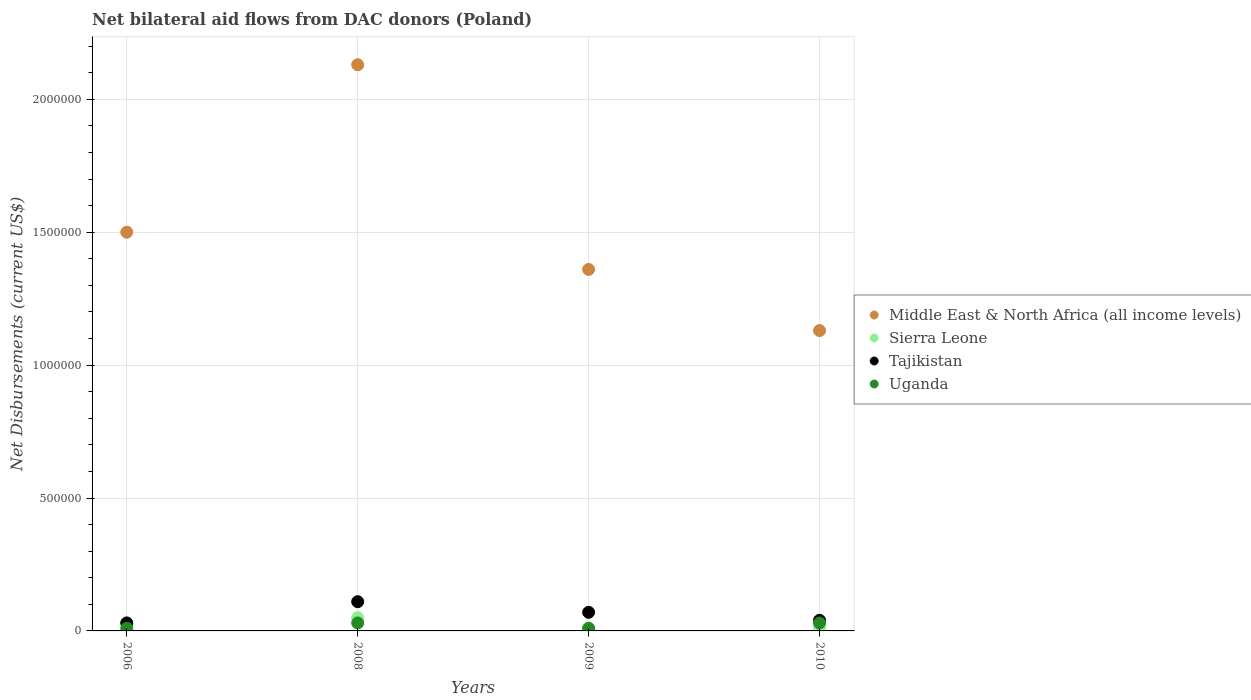Is the number of dotlines equal to the number of legend labels?
Provide a succinct answer. Yes. What is the net bilateral aid flows in Uganda in 2008?
Offer a terse response. 3.00e+04. Across all years, what is the maximum net bilateral aid flows in Middle East & North Africa (all income levels)?
Give a very brief answer. 2.13e+06. Across all years, what is the minimum net bilateral aid flows in Middle East & North Africa (all income levels)?
Make the answer very short. 1.13e+06. What is the total net bilateral aid flows in Tajikistan in the graph?
Provide a short and direct response. 2.50e+05. What is the difference between the net bilateral aid flows in Middle East & North Africa (all income levels) in 2009 and that in 2010?
Provide a short and direct response. 2.30e+05. What is the difference between the net bilateral aid flows in Middle East & North Africa (all income levels) in 2010 and the net bilateral aid flows in Uganda in 2009?
Your response must be concise. 1.12e+06. What is the average net bilateral aid flows in Tajikistan per year?
Offer a terse response. 6.25e+04. In the year 2009, what is the difference between the net bilateral aid flows in Tajikistan and net bilateral aid flows in Uganda?
Make the answer very short. 6.00e+04. In how many years, is the net bilateral aid flows in Uganda greater than 1000000 US$?
Keep it short and to the point. 0. What is the ratio of the net bilateral aid flows in Middle East & North Africa (all income levels) in 2006 to that in 2010?
Offer a terse response. 1.33. In how many years, is the net bilateral aid flows in Tajikistan greater than the average net bilateral aid flows in Tajikistan taken over all years?
Your answer should be compact. 2. Is the sum of the net bilateral aid flows in Tajikistan in 2006 and 2008 greater than the maximum net bilateral aid flows in Uganda across all years?
Keep it short and to the point. Yes. How many years are there in the graph?
Give a very brief answer. 4. How are the legend labels stacked?
Your answer should be compact. Vertical. What is the title of the graph?
Make the answer very short. Net bilateral aid flows from DAC donors (Poland). Does "Central African Republic" appear as one of the legend labels in the graph?
Provide a succinct answer. No. What is the label or title of the X-axis?
Provide a short and direct response. Years. What is the label or title of the Y-axis?
Offer a terse response. Net Disbursements (current US$). What is the Net Disbursements (current US$) of Middle East & North Africa (all income levels) in 2006?
Offer a terse response. 1.50e+06. What is the Net Disbursements (current US$) of Sierra Leone in 2006?
Offer a very short reply. 3.00e+04. What is the Net Disbursements (current US$) of Uganda in 2006?
Keep it short and to the point. 10000. What is the Net Disbursements (current US$) in Middle East & North Africa (all income levels) in 2008?
Make the answer very short. 2.13e+06. What is the Net Disbursements (current US$) in Tajikistan in 2008?
Give a very brief answer. 1.10e+05. What is the Net Disbursements (current US$) of Uganda in 2008?
Your answer should be compact. 3.00e+04. What is the Net Disbursements (current US$) of Middle East & North Africa (all income levels) in 2009?
Offer a terse response. 1.36e+06. What is the Net Disbursements (current US$) in Sierra Leone in 2009?
Offer a terse response. 10000. What is the Net Disbursements (current US$) of Tajikistan in 2009?
Your answer should be very brief. 7.00e+04. What is the Net Disbursements (current US$) of Middle East & North Africa (all income levels) in 2010?
Your answer should be very brief. 1.13e+06. Across all years, what is the maximum Net Disbursements (current US$) of Middle East & North Africa (all income levels)?
Your answer should be very brief. 2.13e+06. Across all years, what is the maximum Net Disbursements (current US$) in Sierra Leone?
Offer a terse response. 5.00e+04. Across all years, what is the maximum Net Disbursements (current US$) of Uganda?
Keep it short and to the point. 3.00e+04. Across all years, what is the minimum Net Disbursements (current US$) in Middle East & North Africa (all income levels)?
Your response must be concise. 1.13e+06. What is the total Net Disbursements (current US$) in Middle East & North Africa (all income levels) in the graph?
Give a very brief answer. 6.12e+06. What is the total Net Disbursements (current US$) of Sierra Leone in the graph?
Provide a succinct answer. 1.00e+05. What is the difference between the Net Disbursements (current US$) in Middle East & North Africa (all income levels) in 2006 and that in 2008?
Provide a succinct answer. -6.30e+05. What is the difference between the Net Disbursements (current US$) in Sierra Leone in 2006 and that in 2008?
Ensure brevity in your answer.  -2.00e+04. What is the difference between the Net Disbursements (current US$) in Tajikistan in 2006 and that in 2008?
Ensure brevity in your answer.  -8.00e+04. What is the difference between the Net Disbursements (current US$) of Tajikistan in 2006 and that in 2009?
Keep it short and to the point. -4.00e+04. What is the difference between the Net Disbursements (current US$) of Uganda in 2006 and that in 2009?
Offer a very short reply. 0. What is the difference between the Net Disbursements (current US$) of Middle East & North Africa (all income levels) in 2006 and that in 2010?
Your answer should be very brief. 3.70e+05. What is the difference between the Net Disbursements (current US$) of Tajikistan in 2006 and that in 2010?
Give a very brief answer. -10000. What is the difference between the Net Disbursements (current US$) in Uganda in 2006 and that in 2010?
Provide a succinct answer. -2.00e+04. What is the difference between the Net Disbursements (current US$) in Middle East & North Africa (all income levels) in 2008 and that in 2009?
Your answer should be compact. 7.70e+05. What is the difference between the Net Disbursements (current US$) of Sierra Leone in 2008 and that in 2009?
Keep it short and to the point. 4.00e+04. What is the difference between the Net Disbursements (current US$) in Tajikistan in 2008 and that in 2009?
Make the answer very short. 4.00e+04. What is the difference between the Net Disbursements (current US$) in Uganda in 2008 and that in 2009?
Offer a terse response. 2.00e+04. What is the difference between the Net Disbursements (current US$) of Middle East & North Africa (all income levels) in 2008 and that in 2010?
Your answer should be very brief. 1.00e+06. What is the difference between the Net Disbursements (current US$) in Tajikistan in 2009 and that in 2010?
Offer a very short reply. 3.00e+04. What is the difference between the Net Disbursements (current US$) in Middle East & North Africa (all income levels) in 2006 and the Net Disbursements (current US$) in Sierra Leone in 2008?
Give a very brief answer. 1.45e+06. What is the difference between the Net Disbursements (current US$) in Middle East & North Africa (all income levels) in 2006 and the Net Disbursements (current US$) in Tajikistan in 2008?
Ensure brevity in your answer.  1.39e+06. What is the difference between the Net Disbursements (current US$) of Middle East & North Africa (all income levels) in 2006 and the Net Disbursements (current US$) of Uganda in 2008?
Your answer should be very brief. 1.47e+06. What is the difference between the Net Disbursements (current US$) of Sierra Leone in 2006 and the Net Disbursements (current US$) of Tajikistan in 2008?
Your answer should be compact. -8.00e+04. What is the difference between the Net Disbursements (current US$) in Sierra Leone in 2006 and the Net Disbursements (current US$) in Uganda in 2008?
Offer a very short reply. 0. What is the difference between the Net Disbursements (current US$) in Tajikistan in 2006 and the Net Disbursements (current US$) in Uganda in 2008?
Make the answer very short. 0. What is the difference between the Net Disbursements (current US$) in Middle East & North Africa (all income levels) in 2006 and the Net Disbursements (current US$) in Sierra Leone in 2009?
Give a very brief answer. 1.49e+06. What is the difference between the Net Disbursements (current US$) of Middle East & North Africa (all income levels) in 2006 and the Net Disbursements (current US$) of Tajikistan in 2009?
Give a very brief answer. 1.43e+06. What is the difference between the Net Disbursements (current US$) of Middle East & North Africa (all income levels) in 2006 and the Net Disbursements (current US$) of Uganda in 2009?
Keep it short and to the point. 1.49e+06. What is the difference between the Net Disbursements (current US$) in Tajikistan in 2006 and the Net Disbursements (current US$) in Uganda in 2009?
Ensure brevity in your answer.  2.00e+04. What is the difference between the Net Disbursements (current US$) of Middle East & North Africa (all income levels) in 2006 and the Net Disbursements (current US$) of Sierra Leone in 2010?
Your response must be concise. 1.49e+06. What is the difference between the Net Disbursements (current US$) of Middle East & North Africa (all income levels) in 2006 and the Net Disbursements (current US$) of Tajikistan in 2010?
Your answer should be compact. 1.46e+06. What is the difference between the Net Disbursements (current US$) of Middle East & North Africa (all income levels) in 2006 and the Net Disbursements (current US$) of Uganda in 2010?
Your answer should be very brief. 1.47e+06. What is the difference between the Net Disbursements (current US$) of Sierra Leone in 2006 and the Net Disbursements (current US$) of Tajikistan in 2010?
Keep it short and to the point. -10000. What is the difference between the Net Disbursements (current US$) in Sierra Leone in 2006 and the Net Disbursements (current US$) in Uganda in 2010?
Offer a terse response. 0. What is the difference between the Net Disbursements (current US$) of Middle East & North Africa (all income levels) in 2008 and the Net Disbursements (current US$) of Sierra Leone in 2009?
Your answer should be compact. 2.12e+06. What is the difference between the Net Disbursements (current US$) of Middle East & North Africa (all income levels) in 2008 and the Net Disbursements (current US$) of Tajikistan in 2009?
Offer a very short reply. 2.06e+06. What is the difference between the Net Disbursements (current US$) of Middle East & North Africa (all income levels) in 2008 and the Net Disbursements (current US$) of Uganda in 2009?
Ensure brevity in your answer.  2.12e+06. What is the difference between the Net Disbursements (current US$) of Sierra Leone in 2008 and the Net Disbursements (current US$) of Tajikistan in 2009?
Keep it short and to the point. -2.00e+04. What is the difference between the Net Disbursements (current US$) in Sierra Leone in 2008 and the Net Disbursements (current US$) in Uganda in 2009?
Provide a succinct answer. 4.00e+04. What is the difference between the Net Disbursements (current US$) in Middle East & North Africa (all income levels) in 2008 and the Net Disbursements (current US$) in Sierra Leone in 2010?
Offer a very short reply. 2.12e+06. What is the difference between the Net Disbursements (current US$) of Middle East & North Africa (all income levels) in 2008 and the Net Disbursements (current US$) of Tajikistan in 2010?
Give a very brief answer. 2.09e+06. What is the difference between the Net Disbursements (current US$) of Middle East & North Africa (all income levels) in 2008 and the Net Disbursements (current US$) of Uganda in 2010?
Give a very brief answer. 2.10e+06. What is the difference between the Net Disbursements (current US$) of Tajikistan in 2008 and the Net Disbursements (current US$) of Uganda in 2010?
Provide a succinct answer. 8.00e+04. What is the difference between the Net Disbursements (current US$) of Middle East & North Africa (all income levels) in 2009 and the Net Disbursements (current US$) of Sierra Leone in 2010?
Ensure brevity in your answer.  1.35e+06. What is the difference between the Net Disbursements (current US$) of Middle East & North Africa (all income levels) in 2009 and the Net Disbursements (current US$) of Tajikistan in 2010?
Provide a short and direct response. 1.32e+06. What is the difference between the Net Disbursements (current US$) in Middle East & North Africa (all income levels) in 2009 and the Net Disbursements (current US$) in Uganda in 2010?
Offer a very short reply. 1.33e+06. What is the difference between the Net Disbursements (current US$) in Sierra Leone in 2009 and the Net Disbursements (current US$) in Tajikistan in 2010?
Make the answer very short. -3.00e+04. What is the difference between the Net Disbursements (current US$) of Tajikistan in 2009 and the Net Disbursements (current US$) of Uganda in 2010?
Ensure brevity in your answer.  4.00e+04. What is the average Net Disbursements (current US$) of Middle East & North Africa (all income levels) per year?
Ensure brevity in your answer.  1.53e+06. What is the average Net Disbursements (current US$) in Sierra Leone per year?
Your response must be concise. 2.50e+04. What is the average Net Disbursements (current US$) in Tajikistan per year?
Give a very brief answer. 6.25e+04. What is the average Net Disbursements (current US$) of Uganda per year?
Provide a short and direct response. 2.00e+04. In the year 2006, what is the difference between the Net Disbursements (current US$) in Middle East & North Africa (all income levels) and Net Disbursements (current US$) in Sierra Leone?
Provide a succinct answer. 1.47e+06. In the year 2006, what is the difference between the Net Disbursements (current US$) in Middle East & North Africa (all income levels) and Net Disbursements (current US$) in Tajikistan?
Offer a terse response. 1.47e+06. In the year 2006, what is the difference between the Net Disbursements (current US$) of Middle East & North Africa (all income levels) and Net Disbursements (current US$) of Uganda?
Provide a short and direct response. 1.49e+06. In the year 2006, what is the difference between the Net Disbursements (current US$) of Sierra Leone and Net Disbursements (current US$) of Tajikistan?
Ensure brevity in your answer.  0. In the year 2006, what is the difference between the Net Disbursements (current US$) in Sierra Leone and Net Disbursements (current US$) in Uganda?
Offer a very short reply. 2.00e+04. In the year 2006, what is the difference between the Net Disbursements (current US$) in Tajikistan and Net Disbursements (current US$) in Uganda?
Your response must be concise. 2.00e+04. In the year 2008, what is the difference between the Net Disbursements (current US$) of Middle East & North Africa (all income levels) and Net Disbursements (current US$) of Sierra Leone?
Provide a succinct answer. 2.08e+06. In the year 2008, what is the difference between the Net Disbursements (current US$) in Middle East & North Africa (all income levels) and Net Disbursements (current US$) in Tajikistan?
Give a very brief answer. 2.02e+06. In the year 2008, what is the difference between the Net Disbursements (current US$) of Middle East & North Africa (all income levels) and Net Disbursements (current US$) of Uganda?
Make the answer very short. 2.10e+06. In the year 2008, what is the difference between the Net Disbursements (current US$) in Sierra Leone and Net Disbursements (current US$) in Tajikistan?
Ensure brevity in your answer.  -6.00e+04. In the year 2008, what is the difference between the Net Disbursements (current US$) in Sierra Leone and Net Disbursements (current US$) in Uganda?
Give a very brief answer. 2.00e+04. In the year 2008, what is the difference between the Net Disbursements (current US$) in Tajikistan and Net Disbursements (current US$) in Uganda?
Provide a succinct answer. 8.00e+04. In the year 2009, what is the difference between the Net Disbursements (current US$) of Middle East & North Africa (all income levels) and Net Disbursements (current US$) of Sierra Leone?
Keep it short and to the point. 1.35e+06. In the year 2009, what is the difference between the Net Disbursements (current US$) in Middle East & North Africa (all income levels) and Net Disbursements (current US$) in Tajikistan?
Offer a terse response. 1.29e+06. In the year 2009, what is the difference between the Net Disbursements (current US$) in Middle East & North Africa (all income levels) and Net Disbursements (current US$) in Uganda?
Offer a terse response. 1.35e+06. In the year 2009, what is the difference between the Net Disbursements (current US$) of Sierra Leone and Net Disbursements (current US$) of Tajikistan?
Give a very brief answer. -6.00e+04. In the year 2009, what is the difference between the Net Disbursements (current US$) of Sierra Leone and Net Disbursements (current US$) of Uganda?
Your response must be concise. 0. In the year 2009, what is the difference between the Net Disbursements (current US$) in Tajikistan and Net Disbursements (current US$) in Uganda?
Your response must be concise. 6.00e+04. In the year 2010, what is the difference between the Net Disbursements (current US$) in Middle East & North Africa (all income levels) and Net Disbursements (current US$) in Sierra Leone?
Ensure brevity in your answer.  1.12e+06. In the year 2010, what is the difference between the Net Disbursements (current US$) of Middle East & North Africa (all income levels) and Net Disbursements (current US$) of Tajikistan?
Your response must be concise. 1.09e+06. In the year 2010, what is the difference between the Net Disbursements (current US$) of Middle East & North Africa (all income levels) and Net Disbursements (current US$) of Uganda?
Give a very brief answer. 1.10e+06. In the year 2010, what is the difference between the Net Disbursements (current US$) in Sierra Leone and Net Disbursements (current US$) in Uganda?
Ensure brevity in your answer.  -2.00e+04. What is the ratio of the Net Disbursements (current US$) in Middle East & North Africa (all income levels) in 2006 to that in 2008?
Provide a short and direct response. 0.7. What is the ratio of the Net Disbursements (current US$) of Sierra Leone in 2006 to that in 2008?
Keep it short and to the point. 0.6. What is the ratio of the Net Disbursements (current US$) in Tajikistan in 2006 to that in 2008?
Make the answer very short. 0.27. What is the ratio of the Net Disbursements (current US$) in Uganda in 2006 to that in 2008?
Offer a terse response. 0.33. What is the ratio of the Net Disbursements (current US$) in Middle East & North Africa (all income levels) in 2006 to that in 2009?
Offer a terse response. 1.1. What is the ratio of the Net Disbursements (current US$) in Sierra Leone in 2006 to that in 2009?
Provide a succinct answer. 3. What is the ratio of the Net Disbursements (current US$) in Tajikistan in 2006 to that in 2009?
Offer a very short reply. 0.43. What is the ratio of the Net Disbursements (current US$) in Middle East & North Africa (all income levels) in 2006 to that in 2010?
Make the answer very short. 1.33. What is the ratio of the Net Disbursements (current US$) of Sierra Leone in 2006 to that in 2010?
Your response must be concise. 3. What is the ratio of the Net Disbursements (current US$) in Uganda in 2006 to that in 2010?
Offer a terse response. 0.33. What is the ratio of the Net Disbursements (current US$) of Middle East & North Africa (all income levels) in 2008 to that in 2009?
Your response must be concise. 1.57. What is the ratio of the Net Disbursements (current US$) in Sierra Leone in 2008 to that in 2009?
Ensure brevity in your answer.  5. What is the ratio of the Net Disbursements (current US$) of Tajikistan in 2008 to that in 2009?
Keep it short and to the point. 1.57. What is the ratio of the Net Disbursements (current US$) in Middle East & North Africa (all income levels) in 2008 to that in 2010?
Your response must be concise. 1.89. What is the ratio of the Net Disbursements (current US$) of Sierra Leone in 2008 to that in 2010?
Offer a terse response. 5. What is the ratio of the Net Disbursements (current US$) of Tajikistan in 2008 to that in 2010?
Provide a succinct answer. 2.75. What is the ratio of the Net Disbursements (current US$) of Uganda in 2008 to that in 2010?
Provide a short and direct response. 1. What is the ratio of the Net Disbursements (current US$) of Middle East & North Africa (all income levels) in 2009 to that in 2010?
Your answer should be compact. 1.2. What is the ratio of the Net Disbursements (current US$) of Sierra Leone in 2009 to that in 2010?
Your response must be concise. 1. What is the ratio of the Net Disbursements (current US$) in Tajikistan in 2009 to that in 2010?
Your response must be concise. 1.75. What is the ratio of the Net Disbursements (current US$) in Uganda in 2009 to that in 2010?
Ensure brevity in your answer.  0.33. What is the difference between the highest and the second highest Net Disbursements (current US$) in Middle East & North Africa (all income levels)?
Offer a terse response. 6.30e+05. What is the difference between the highest and the second highest Net Disbursements (current US$) in Tajikistan?
Provide a short and direct response. 4.00e+04. What is the difference between the highest and the second highest Net Disbursements (current US$) in Uganda?
Make the answer very short. 0. What is the difference between the highest and the lowest Net Disbursements (current US$) in Middle East & North Africa (all income levels)?
Your answer should be compact. 1.00e+06. What is the difference between the highest and the lowest Net Disbursements (current US$) in Tajikistan?
Provide a succinct answer. 8.00e+04. 